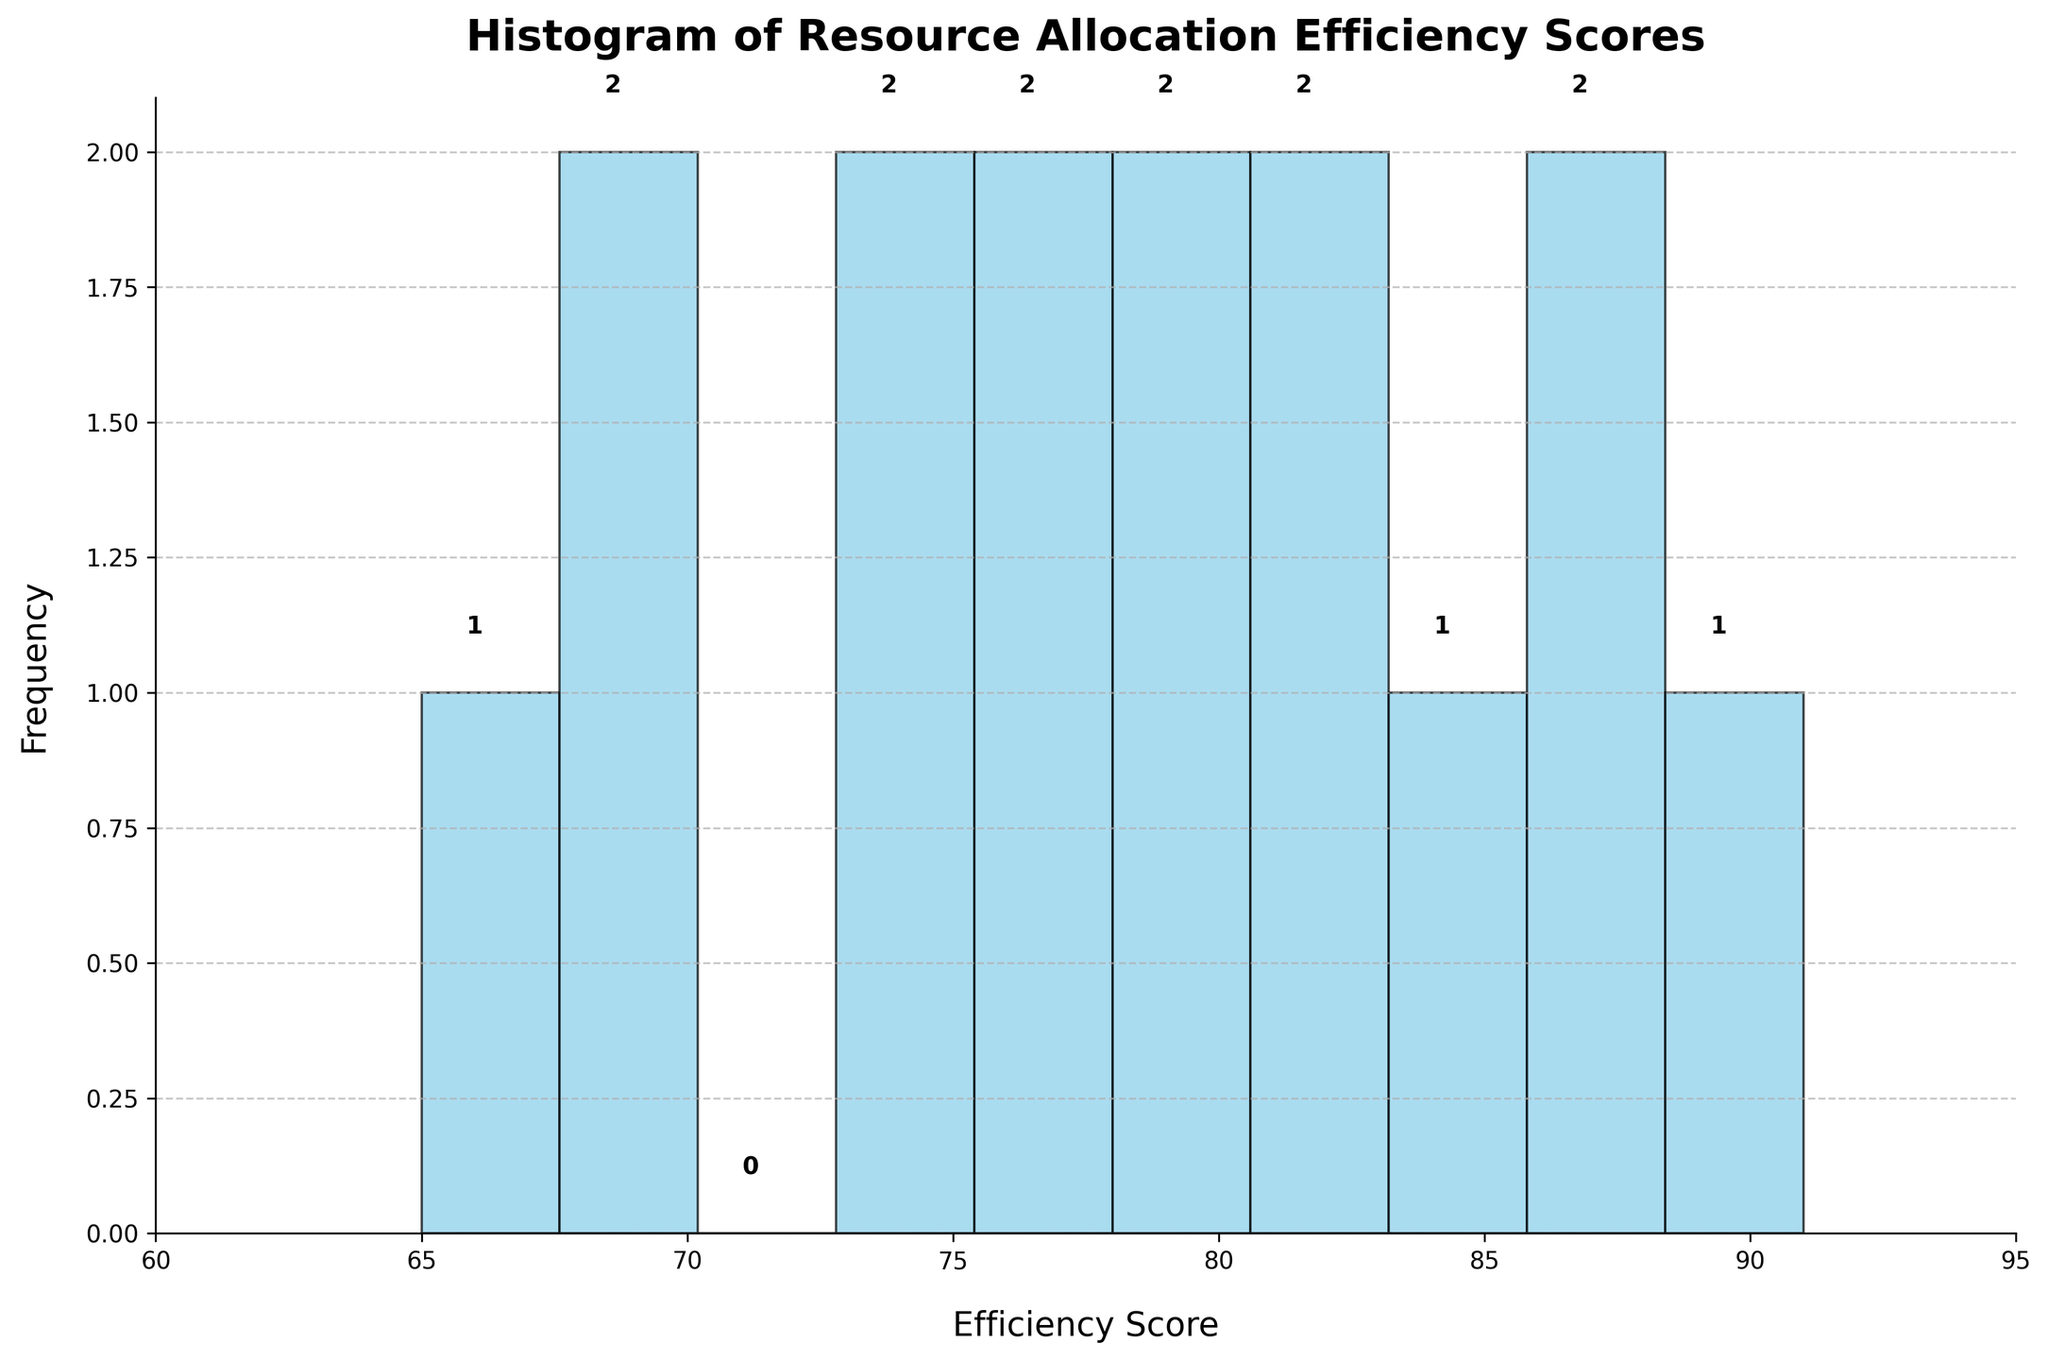How many efficiency scores fall into the 75-80 range? Look at the histogram bar that covers the 75-80 range and count the frequency indicated by the bar height.
Answer: 3 What is the title of the histogram? The title is usually found at the top of the histogram in big bold letters.
Answer: Histogram of Resource Allocation Efficiency Scores What is the highest frequency of efficiency scores in any range? Identify the tallest bar in the histogram and read the frequency value from the y-axis.
Answer: 4 Which efficiency score range has the least frequency? Find the shortest bar in the histogram and check the corresponding efficiency score range it covers.
Answer: 60-65 How many strategies have an efficiency score below 70? Identify the bars covering the ranges below 70 and sum their frequencies.
Answer: 2 What's the approximate average efficiency score for the procurement strategies shown? Sum all the mid-points of each bar’s range multiplied by their frequencies, then divide by the total number of strategies. (Example: (65*1 + 68*1 + ... + 91*1) / 15)
Answer: 78 Which efficiency score group includes the score 76? Check the bar ranges and find where the value 76 fits.
Answer: 75-80 Does the histogram indicate if the strategy "Rapid Response Teams" is effective in resource allocation? Check which bar includes the efficiency score for "Rapid Response Teams" and note its height (frequency).
Answer: Yes, it falls in the 90-95 range, which is very effective Are there any efficiency scores above 90? Glance through the bars on the higher end of the histogram to see if any cover scores above 90.
Answer: Yes How many bars are on the histogram? Count the number of distinct vertical bars on the histogram.
Answer: 9 